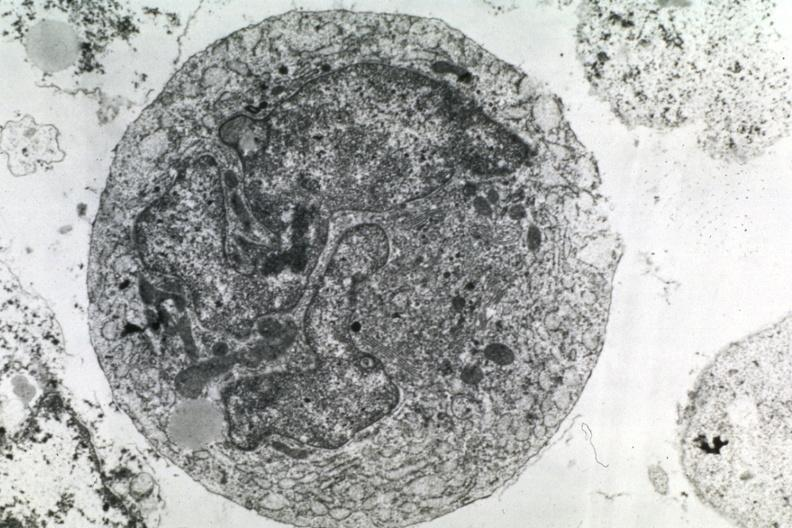s chest and abdomen slide present?
Answer the question using a single word or phrase. No 